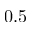<formula> <loc_0><loc_0><loc_500><loc_500>0 . 5</formula> 